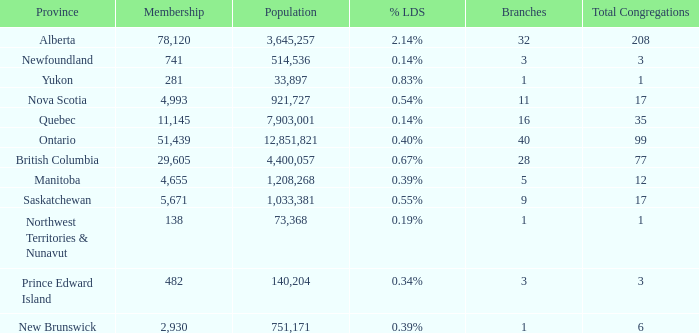What's the sum of the total congregation in the manitoba province with less than 1,208,268 population? None. 